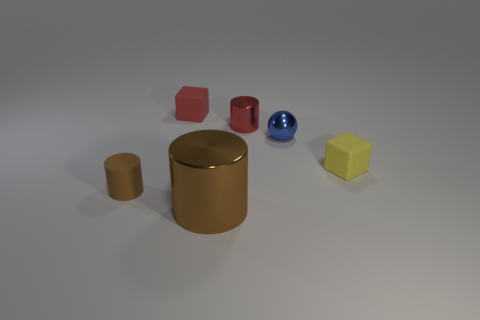Are any tiny brown rubber things visible? Yes, there is a small, brown cylindrical object that could appear like a tiny rubber piece among the various geometric shapes shown in the image. 